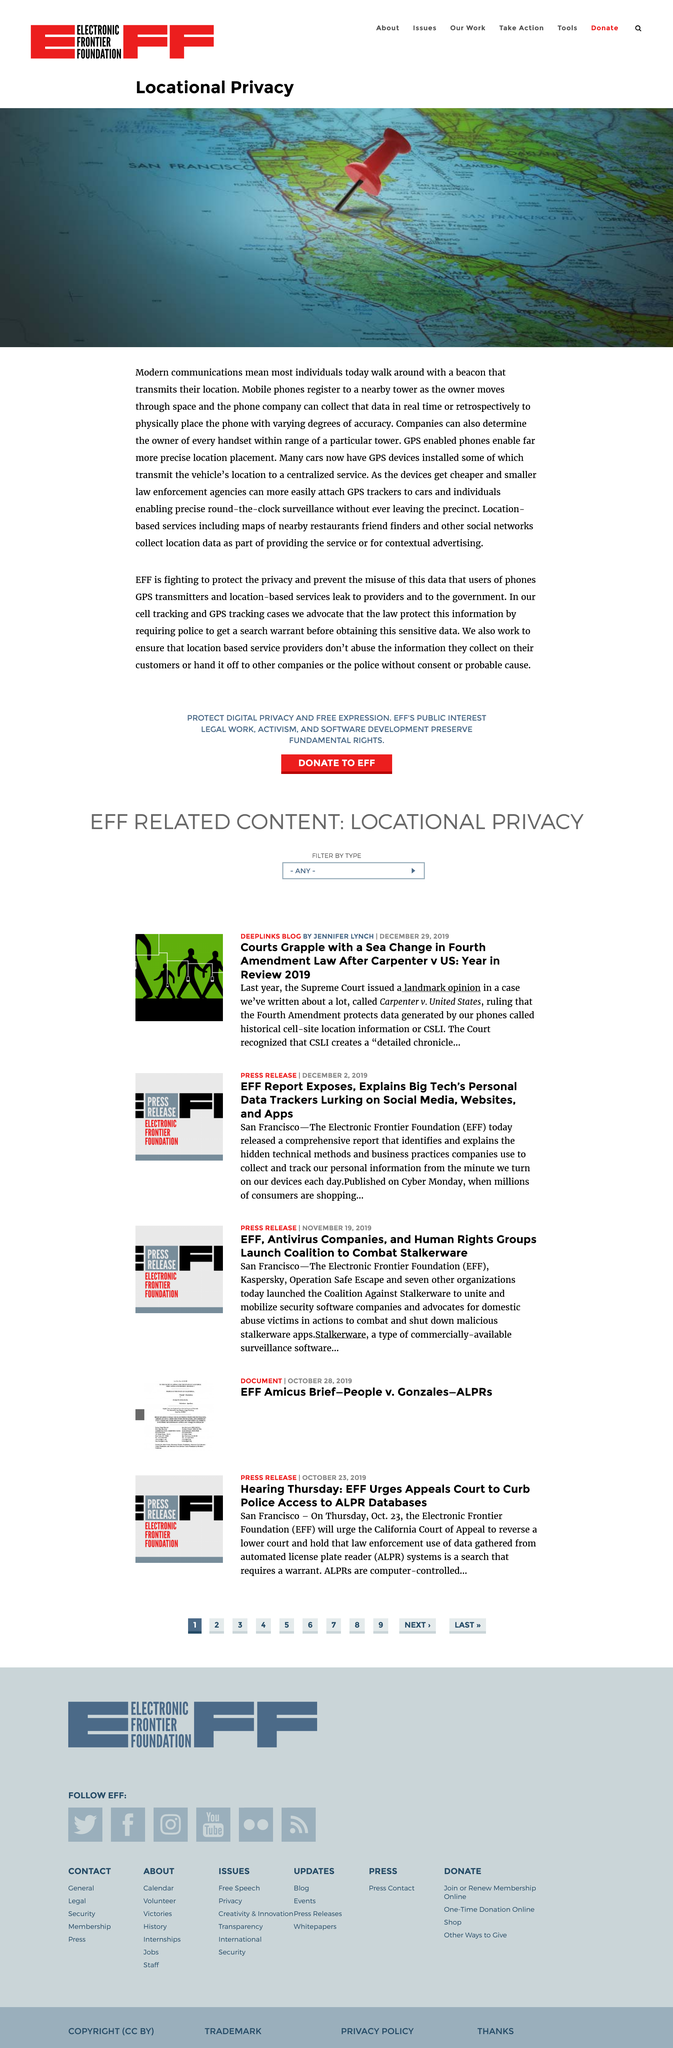Mention a couple of crucial points in this snapshot. Mobile phones register with nearby towers in order to establish and maintain communication with the cellular network. It can be declared that many cars have GPS systems. Yes, it is possible to easily attach a GPS to a car. 